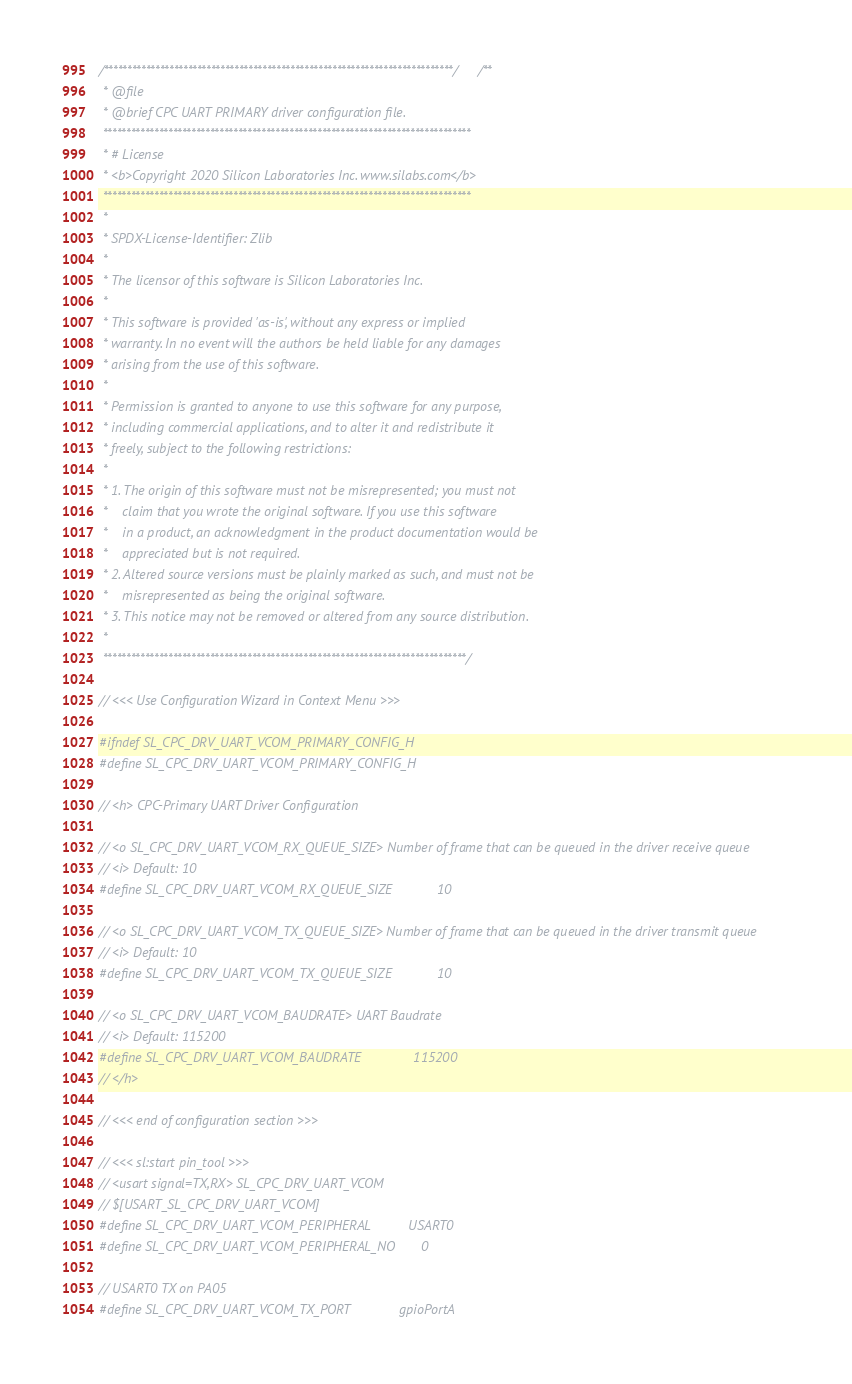Convert code to text. <code><loc_0><loc_0><loc_500><loc_500><_C_>/***************************************************************************//**
 * @file
 * @brief CPC UART PRIMARY driver configuration file.
 *******************************************************************************
 * # License
 * <b>Copyright 2020 Silicon Laboratories Inc. www.silabs.com</b>
 *******************************************************************************
 *
 * SPDX-License-Identifier: Zlib
 *
 * The licensor of this software is Silicon Laboratories Inc.
 *
 * This software is provided 'as-is', without any express or implied
 * warranty. In no event will the authors be held liable for any damages
 * arising from the use of this software.
 *
 * Permission is granted to anyone to use this software for any purpose,
 * including commercial applications, and to alter it and redistribute it
 * freely, subject to the following restrictions:
 *
 * 1. The origin of this software must not be misrepresented; you must not
 *    claim that you wrote the original software. If you use this software
 *    in a product, an acknowledgment in the product documentation would be
 *    appreciated but is not required.
 * 2. Altered source versions must be plainly marked as such, and must not be
 *    misrepresented as being the original software.
 * 3. This notice may not be removed or altered from any source distribution.
 *
 ******************************************************************************/

// <<< Use Configuration Wizard in Context Menu >>>

#ifndef SL_CPC_DRV_UART_VCOM_PRIMARY_CONFIG_H
#define SL_CPC_DRV_UART_VCOM_PRIMARY_CONFIG_H

// <h> CPC-Primary UART Driver Configuration

// <o SL_CPC_DRV_UART_VCOM_RX_QUEUE_SIZE> Number of frame that can be queued in the driver receive queue
// <i> Default: 10
#define SL_CPC_DRV_UART_VCOM_RX_QUEUE_SIZE            10

// <o SL_CPC_DRV_UART_VCOM_TX_QUEUE_SIZE> Number of frame that can be queued in the driver transmit queue
// <i> Default: 10
#define SL_CPC_DRV_UART_VCOM_TX_QUEUE_SIZE            10

// <o SL_CPC_DRV_UART_VCOM_BAUDRATE> UART Baudrate
// <i> Default: 115200
#define SL_CPC_DRV_UART_VCOM_BAUDRATE              115200
// </h>

// <<< end of configuration section >>>

// <<< sl:start pin_tool >>>
// <usart signal=TX,RX> SL_CPC_DRV_UART_VCOM
// $[USART_SL_CPC_DRV_UART_VCOM]
#define SL_CPC_DRV_UART_VCOM_PERIPHERAL          USART0
#define SL_CPC_DRV_UART_VCOM_PERIPHERAL_NO       0

// USART0 TX on PA05
#define SL_CPC_DRV_UART_VCOM_TX_PORT             gpioPortA</code> 